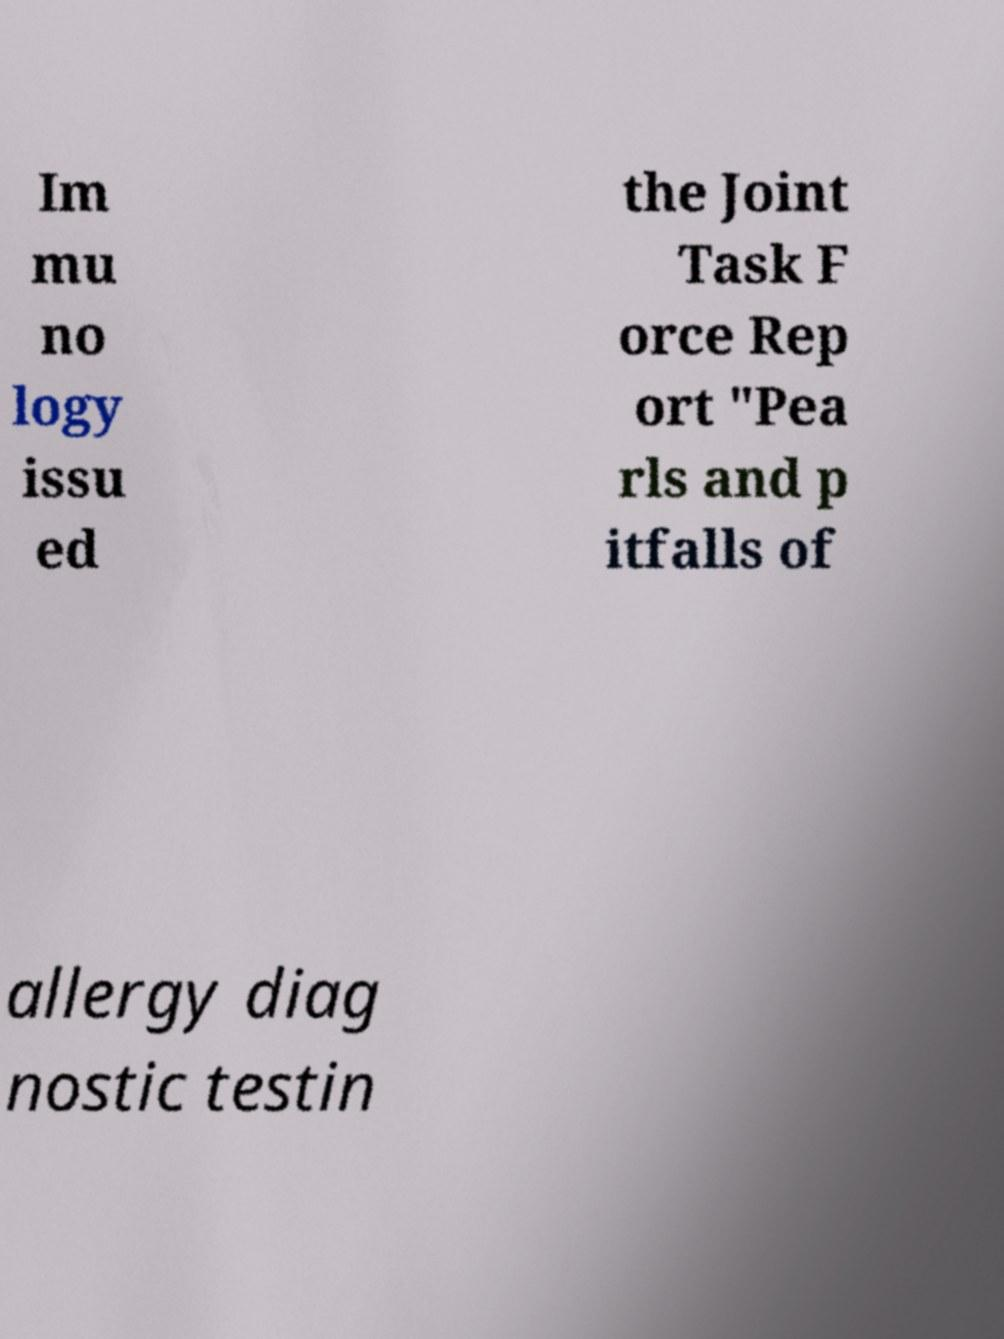Please read and relay the text visible in this image. What does it say? Im mu no logy issu ed the Joint Task F orce Rep ort "Pea rls and p itfalls of allergy diag nostic testin 